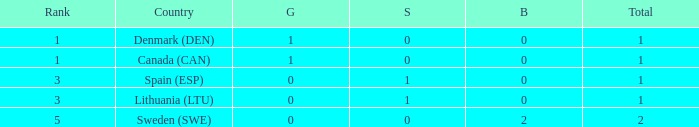What is the rank when there is 0 gold, the total is more than 1, and silver is more than 0? None. 